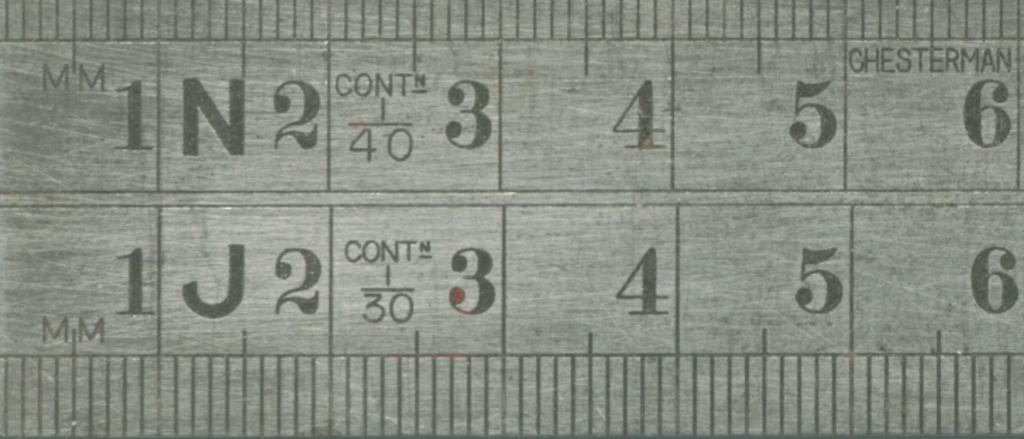<image>
Present a compact description of the photo's key features. Ruler that says MM on the left side and the number 1 next to it. 